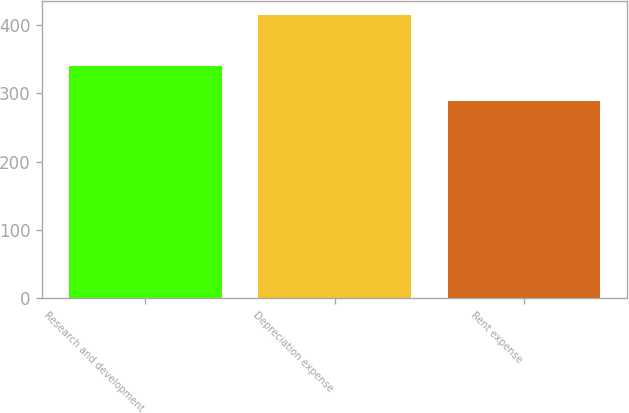Convert chart to OTSL. <chart><loc_0><loc_0><loc_500><loc_500><bar_chart><fcel>Research and development<fcel>Depreciation expense<fcel>Rent expense<nl><fcel>340<fcel>414<fcel>289<nl></chart> 